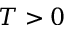<formula> <loc_0><loc_0><loc_500><loc_500>T > 0</formula> 